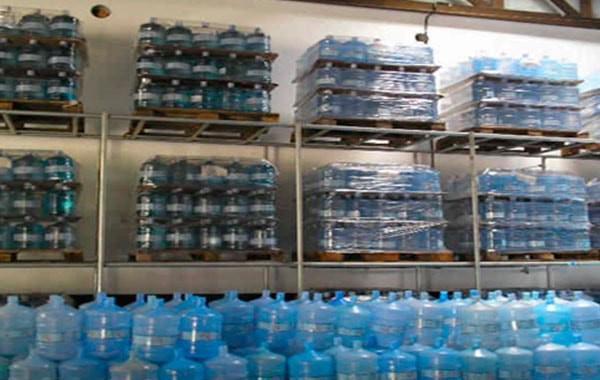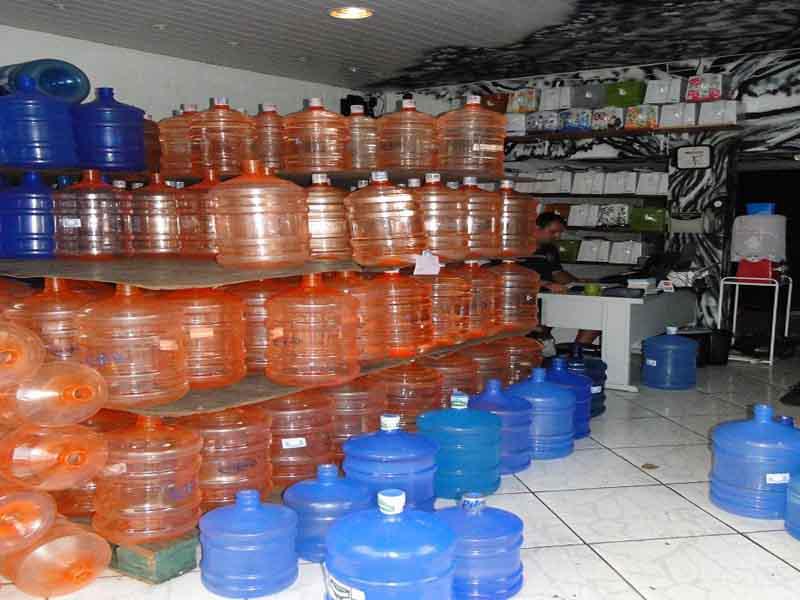The first image is the image on the left, the second image is the image on the right. For the images shown, is this caption "The left image contains no more than one upright water jug, and the right image includes only upright jugs with blue caps." true? Answer yes or no. No. The first image is the image on the left, the second image is the image on the right. For the images displayed, is the sentence "There are less than three bottles in the left image." factually correct? Answer yes or no. No. 